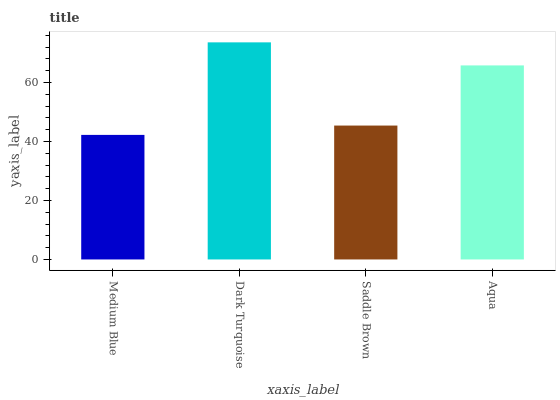Is Medium Blue the minimum?
Answer yes or no. Yes. Is Dark Turquoise the maximum?
Answer yes or no. Yes. Is Saddle Brown the minimum?
Answer yes or no. No. Is Saddle Brown the maximum?
Answer yes or no. No. Is Dark Turquoise greater than Saddle Brown?
Answer yes or no. Yes. Is Saddle Brown less than Dark Turquoise?
Answer yes or no. Yes. Is Saddle Brown greater than Dark Turquoise?
Answer yes or no. No. Is Dark Turquoise less than Saddle Brown?
Answer yes or no. No. Is Aqua the high median?
Answer yes or no. Yes. Is Saddle Brown the low median?
Answer yes or no. Yes. Is Medium Blue the high median?
Answer yes or no. No. Is Medium Blue the low median?
Answer yes or no. No. 